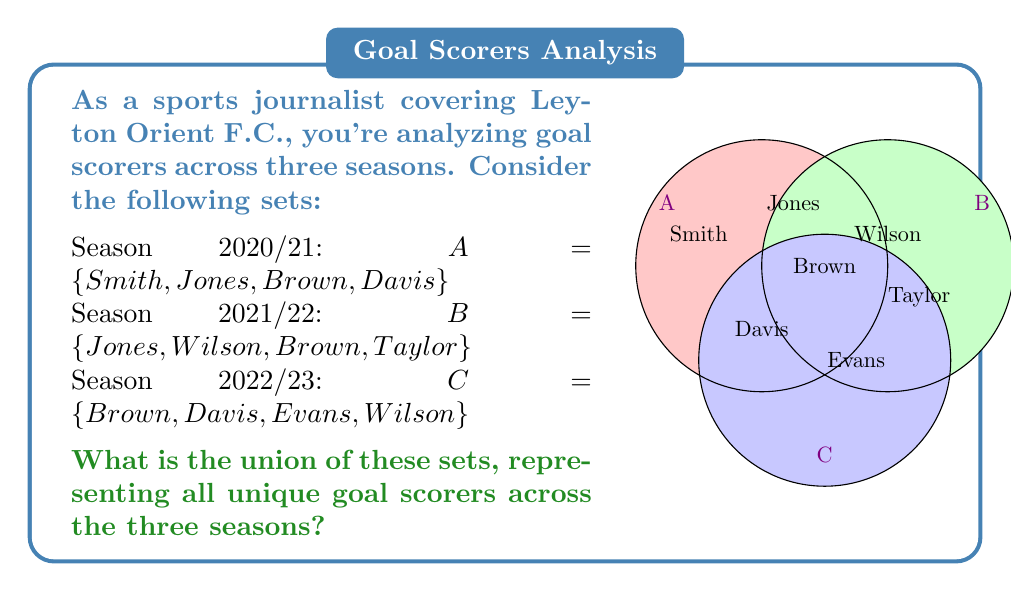Show me your answer to this math problem. To find the union of these sets, we need to combine all unique elements from sets A, B, and C. Let's approach this step-by-step:

1) First, let's write out the formal definition of the union:
   $A \cup B \cup C = \{x | x \in A \text{ or } x \in B \text{ or } x \in C\}$

2) Now, let's list all elements from set A:
   $\{Smith, Jones, Brown, Davis\}$

3) Next, add any new elements from set B that aren't already included:
   $\{Smith, Jones, Brown, Davis, Wilson, Taylor\}$

4) Finally, add any new elements from set C that aren't already included:
   $\{Smith, Jones, Brown, Davis, Wilson, Taylor, Evans\}$

5) We can verify that this includes all elements from each set:
   - All elements from A are included
   - All elements from B are included
   - All elements from C are included

6) The resulting set contains all unique goal scorers across the three seasons, with no duplicates.
Answer: $\{Smith, Jones, Brown, Davis, Wilson, Taylor, Evans\}$ 